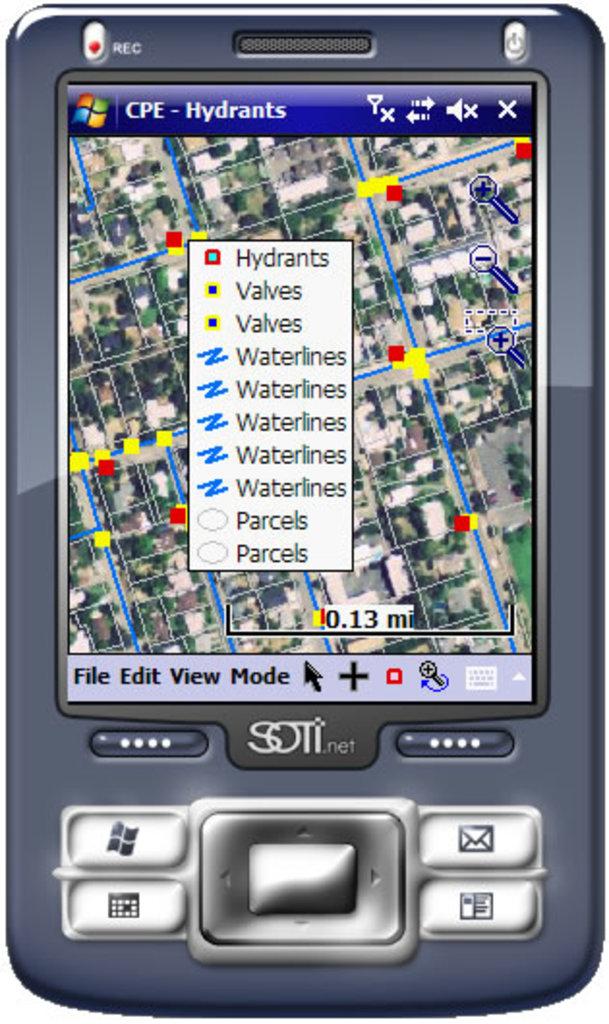What is shown here, waterlines, hydrants, or both?
Offer a very short reply. Both. What type of item has a yellow symbol?
Offer a terse response. Valves. 